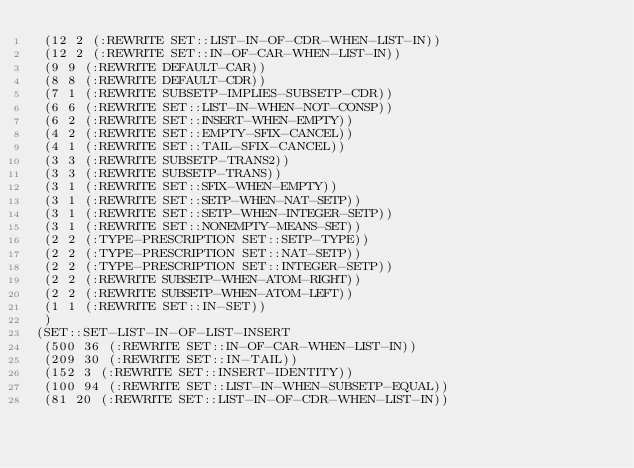<code> <loc_0><loc_0><loc_500><loc_500><_Lisp_> (12 2 (:REWRITE SET::LIST-IN-OF-CDR-WHEN-LIST-IN))
 (12 2 (:REWRITE SET::IN-OF-CAR-WHEN-LIST-IN))
 (9 9 (:REWRITE DEFAULT-CAR))
 (8 8 (:REWRITE DEFAULT-CDR))
 (7 1 (:REWRITE SUBSETP-IMPLIES-SUBSETP-CDR))
 (6 6 (:REWRITE SET::LIST-IN-WHEN-NOT-CONSP))
 (6 2 (:REWRITE SET::INSERT-WHEN-EMPTY))
 (4 2 (:REWRITE SET::EMPTY-SFIX-CANCEL))
 (4 1 (:REWRITE SET::TAIL-SFIX-CANCEL))
 (3 3 (:REWRITE SUBSETP-TRANS2))
 (3 3 (:REWRITE SUBSETP-TRANS))
 (3 1 (:REWRITE SET::SFIX-WHEN-EMPTY))
 (3 1 (:REWRITE SET::SETP-WHEN-NAT-SETP))
 (3 1 (:REWRITE SET::SETP-WHEN-INTEGER-SETP))
 (3 1 (:REWRITE SET::NONEMPTY-MEANS-SET))
 (2 2 (:TYPE-PRESCRIPTION SET::SETP-TYPE))
 (2 2 (:TYPE-PRESCRIPTION SET::NAT-SETP))
 (2 2 (:TYPE-PRESCRIPTION SET::INTEGER-SETP))
 (2 2 (:REWRITE SUBSETP-WHEN-ATOM-RIGHT))
 (2 2 (:REWRITE SUBSETP-WHEN-ATOM-LEFT))
 (1 1 (:REWRITE SET::IN-SET))
 )
(SET::SET-LIST-IN-OF-LIST-INSERT
 (500 36 (:REWRITE SET::IN-OF-CAR-WHEN-LIST-IN))
 (209 30 (:REWRITE SET::IN-TAIL))
 (152 3 (:REWRITE SET::INSERT-IDENTITY))
 (100 94 (:REWRITE SET::LIST-IN-WHEN-SUBSETP-EQUAL))
 (81 20 (:REWRITE SET::LIST-IN-OF-CDR-WHEN-LIST-IN))</code> 